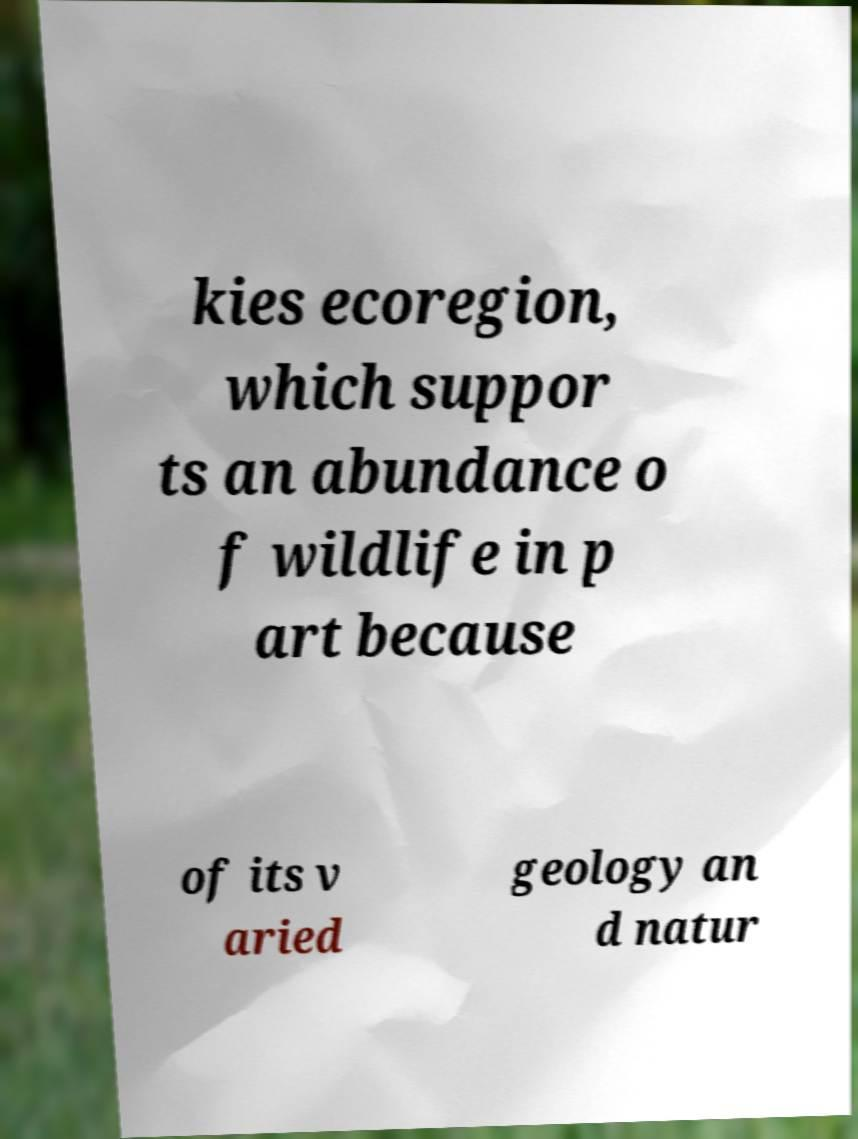Please read and relay the text visible in this image. What does it say? kies ecoregion, which suppor ts an abundance o f wildlife in p art because of its v aried geology an d natur 